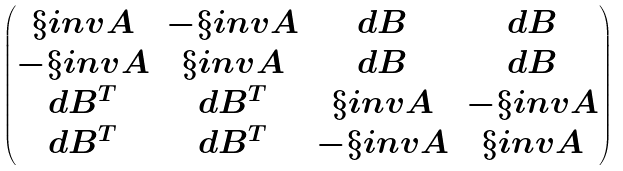<formula> <loc_0><loc_0><loc_500><loc_500>\begin{pmatrix} \S i n v { A } & - \S i n v { A } & d B & d B \\ - \S i n v { A } & \S i n v { A } & d B & d B \\ d B ^ { T } & d B ^ { T } & \S i n v { A } & - \S i n v { A } \\ d B ^ { T } & d B ^ { T } & - \S i n v { A } & \S i n v { A } \\ \end{pmatrix}</formula> 